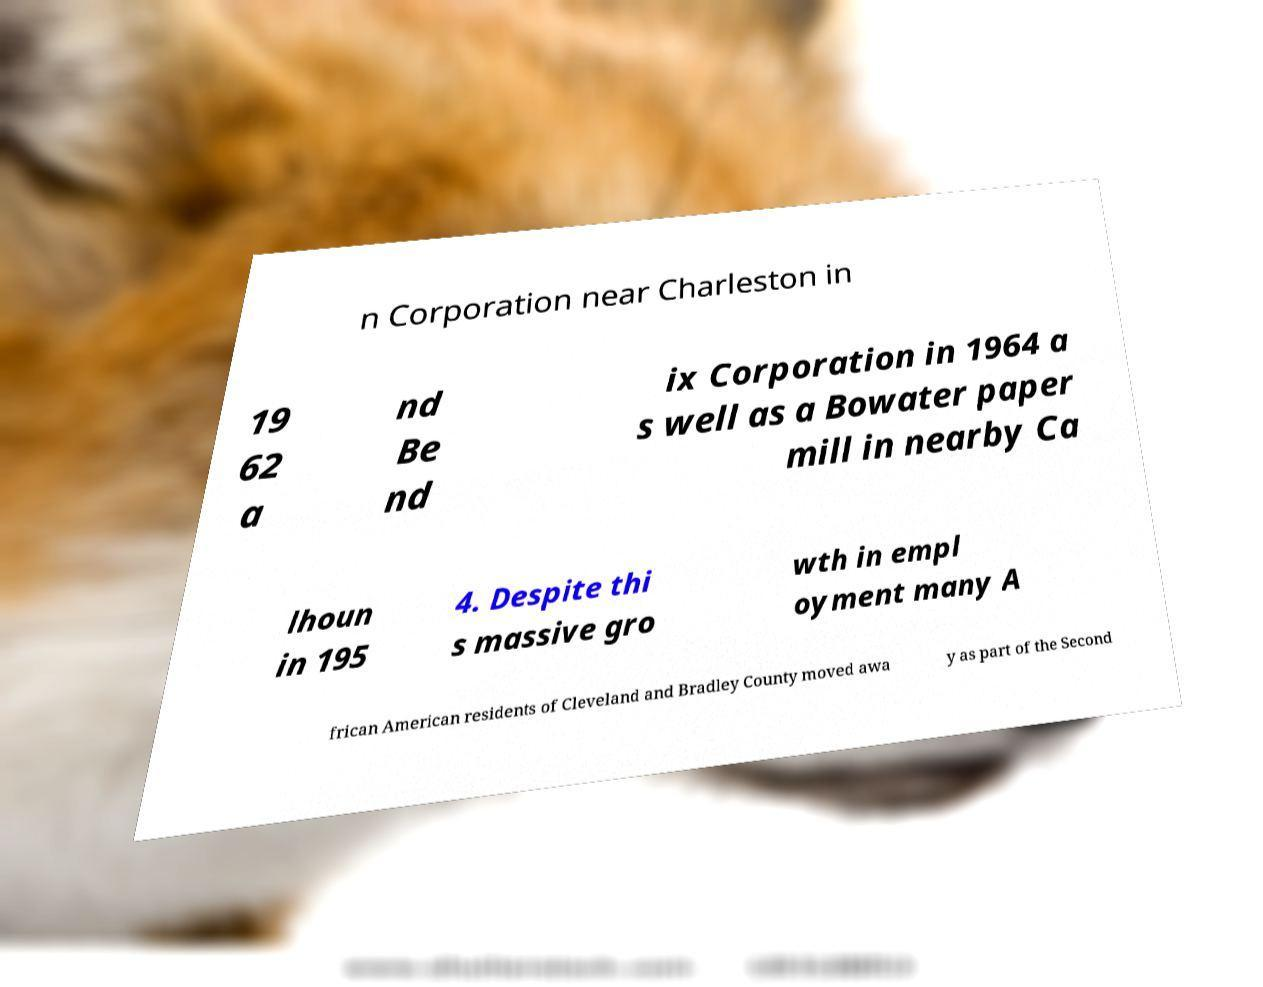Please identify and transcribe the text found in this image. n Corporation near Charleston in 19 62 a nd Be nd ix Corporation in 1964 a s well as a Bowater paper mill in nearby Ca lhoun in 195 4. Despite thi s massive gro wth in empl oyment many A frican American residents of Cleveland and Bradley County moved awa y as part of the Second 